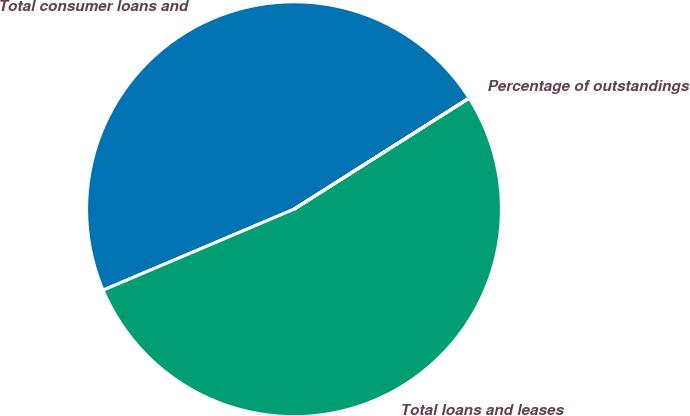Convert chart to OTSL. <chart><loc_0><loc_0><loc_500><loc_500><pie_chart><fcel>Total consumer loans and<fcel>Total loans and leases<fcel>Percentage of outstandings<nl><fcel>47.38%<fcel>52.61%<fcel>0.01%<nl></chart> 